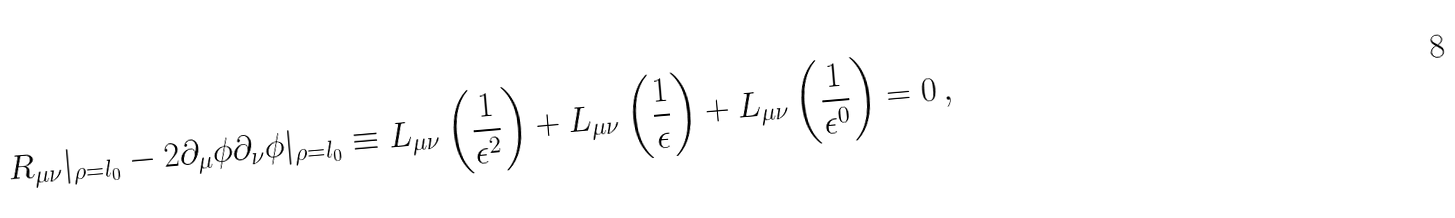<formula> <loc_0><loc_0><loc_500><loc_500>R _ { \mu \nu } | _ { \rho = l _ { 0 } } - 2 \partial _ { \mu } \phi \partial _ { \nu } \phi | _ { \rho = l _ { 0 } } \equiv L _ { \mu \nu } \left ( \frac { 1 } { \epsilon ^ { 2 } } \right ) + L _ { \mu \nu } \left ( \frac { 1 } { \epsilon } \right ) + L _ { \mu \nu } \left ( \frac { 1 } { \epsilon ^ { 0 } } \right ) = 0 \, ,</formula> 